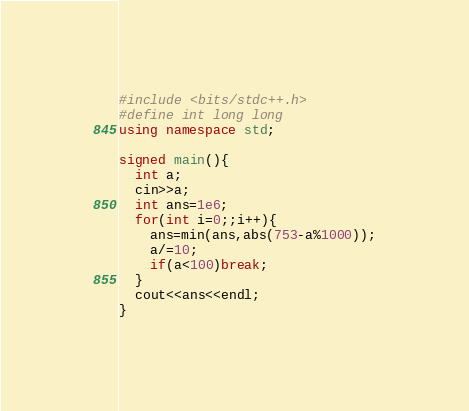Convert code to text. <code><loc_0><loc_0><loc_500><loc_500><_C++_>#include <bits/stdc++.h>
#define int long long
using namespace std;

signed main(){
  int a;
  cin>>a;
  int ans=1e6;
  for(int i=0;;i++){
    ans=min(ans,abs(753-a%1000));
    a/=10;
    if(a<100)break;
  }
  cout<<ans<<endl;
}
</code> 